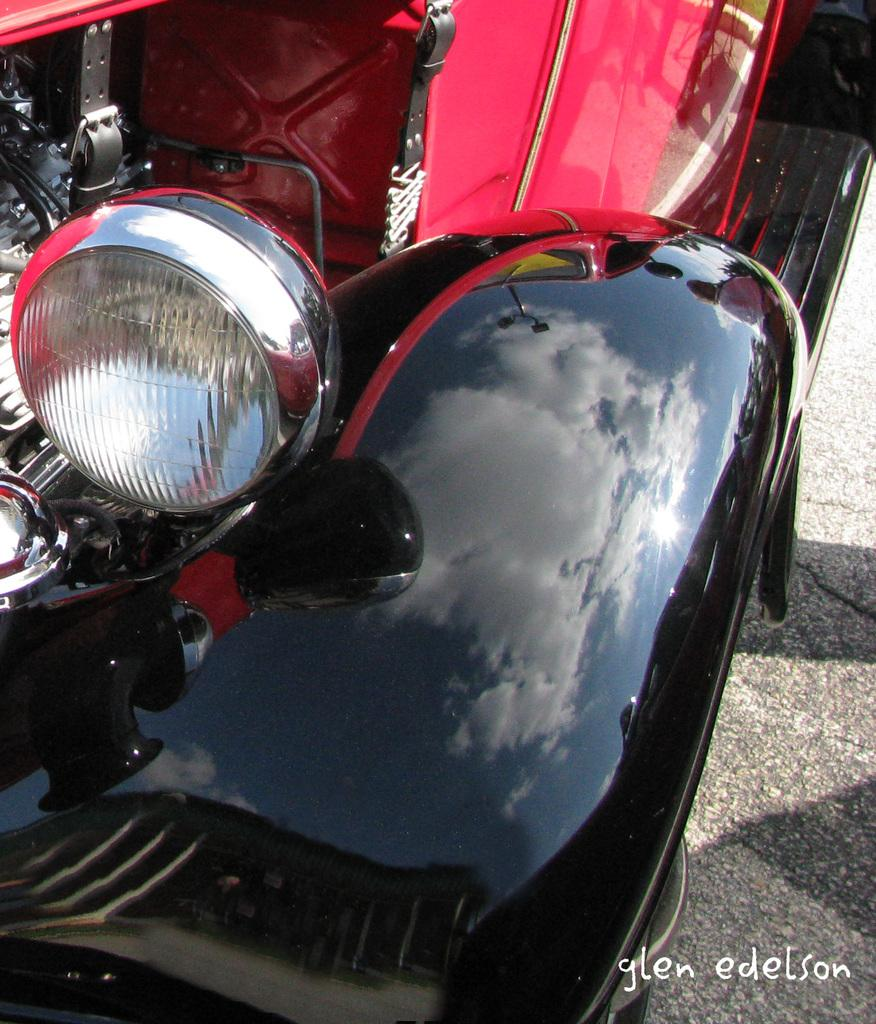What type of vehicle is in the image? There is a vintage car in the image. What colors can be seen on the car? The car is in red and black color. What is visible at the bottom of the image? There is a road at the bottom of the image. Can you tell me what the scarecrow is discussing with the ant in the image? There is no scarecrow or ant present in the image; it features a vintage car and a road. 